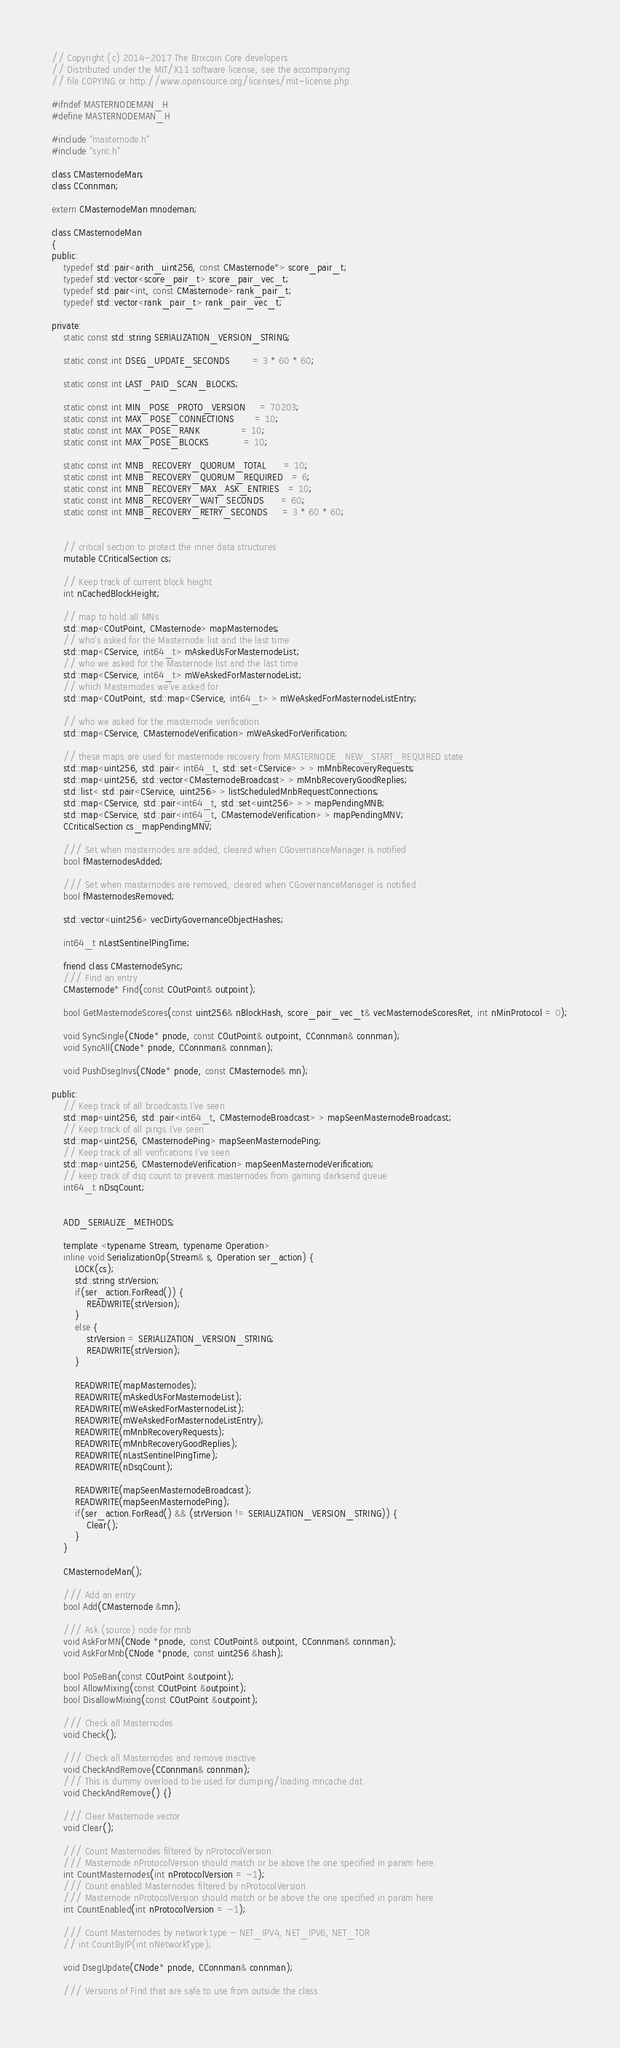<code> <loc_0><loc_0><loc_500><loc_500><_C_>// Copyright (c) 2014-2017 The Brixcoin Core developers
// Distributed under the MIT/X11 software license, see the accompanying
// file COPYING or http://www.opensource.org/licenses/mit-license.php.

#ifndef MASTERNODEMAN_H
#define MASTERNODEMAN_H

#include "masternode.h"
#include "sync.h"

class CMasternodeMan;
class CConnman;

extern CMasternodeMan mnodeman;

class CMasternodeMan
{
public:
    typedef std::pair<arith_uint256, const CMasternode*> score_pair_t;
    typedef std::vector<score_pair_t> score_pair_vec_t;
    typedef std::pair<int, const CMasternode> rank_pair_t;
    typedef std::vector<rank_pair_t> rank_pair_vec_t;

private:
    static const std::string SERIALIZATION_VERSION_STRING;

    static const int DSEG_UPDATE_SECONDS        = 3 * 60 * 60;

    static const int LAST_PAID_SCAN_BLOCKS;

    static const int MIN_POSE_PROTO_VERSION     = 70203;
    static const int MAX_POSE_CONNECTIONS       = 10;
    static const int MAX_POSE_RANK              = 10;
    static const int MAX_POSE_BLOCKS            = 10;

    static const int MNB_RECOVERY_QUORUM_TOTAL      = 10;
    static const int MNB_RECOVERY_QUORUM_REQUIRED   = 6;
    static const int MNB_RECOVERY_MAX_ASK_ENTRIES   = 10;
    static const int MNB_RECOVERY_WAIT_SECONDS      = 60;
    static const int MNB_RECOVERY_RETRY_SECONDS     = 3 * 60 * 60;


    // critical section to protect the inner data structures
    mutable CCriticalSection cs;

    // Keep track of current block height
    int nCachedBlockHeight;

    // map to hold all MNs
    std::map<COutPoint, CMasternode> mapMasternodes;
    // who's asked for the Masternode list and the last time
    std::map<CService, int64_t> mAskedUsForMasternodeList;
    // who we asked for the Masternode list and the last time
    std::map<CService, int64_t> mWeAskedForMasternodeList;
    // which Masternodes we've asked for
    std::map<COutPoint, std::map<CService, int64_t> > mWeAskedForMasternodeListEntry;

    // who we asked for the masternode verification
    std::map<CService, CMasternodeVerification> mWeAskedForVerification;

    // these maps are used for masternode recovery from MASTERNODE_NEW_START_REQUIRED state
    std::map<uint256, std::pair< int64_t, std::set<CService> > > mMnbRecoveryRequests;
    std::map<uint256, std::vector<CMasternodeBroadcast> > mMnbRecoveryGoodReplies;
    std::list< std::pair<CService, uint256> > listScheduledMnbRequestConnections;
    std::map<CService, std::pair<int64_t, std::set<uint256> > > mapPendingMNB;
    std::map<CService, std::pair<int64_t, CMasternodeVerification> > mapPendingMNV;
    CCriticalSection cs_mapPendingMNV;

    /// Set when masternodes are added, cleared when CGovernanceManager is notified
    bool fMasternodesAdded;

    /// Set when masternodes are removed, cleared when CGovernanceManager is notified
    bool fMasternodesRemoved;

    std::vector<uint256> vecDirtyGovernanceObjectHashes;

    int64_t nLastSentinelPingTime;

    friend class CMasternodeSync;
    /// Find an entry
    CMasternode* Find(const COutPoint& outpoint);

    bool GetMasternodeScores(const uint256& nBlockHash, score_pair_vec_t& vecMasternodeScoresRet, int nMinProtocol = 0);

    void SyncSingle(CNode* pnode, const COutPoint& outpoint, CConnman& connman);
    void SyncAll(CNode* pnode, CConnman& connman);

    void PushDsegInvs(CNode* pnode, const CMasternode& mn);

public:
    // Keep track of all broadcasts I've seen
    std::map<uint256, std::pair<int64_t, CMasternodeBroadcast> > mapSeenMasternodeBroadcast;
    // Keep track of all pings I've seen
    std::map<uint256, CMasternodePing> mapSeenMasternodePing;
    // Keep track of all verifications I've seen
    std::map<uint256, CMasternodeVerification> mapSeenMasternodeVerification;
    // keep track of dsq count to prevent masternodes from gaming darksend queue
    int64_t nDsqCount;


    ADD_SERIALIZE_METHODS;

    template <typename Stream, typename Operation>
    inline void SerializationOp(Stream& s, Operation ser_action) {
        LOCK(cs);
        std::string strVersion;
        if(ser_action.ForRead()) {
            READWRITE(strVersion);
        }
        else {
            strVersion = SERIALIZATION_VERSION_STRING; 
            READWRITE(strVersion);
        }

        READWRITE(mapMasternodes);
        READWRITE(mAskedUsForMasternodeList);
        READWRITE(mWeAskedForMasternodeList);
        READWRITE(mWeAskedForMasternodeListEntry);
        READWRITE(mMnbRecoveryRequests);
        READWRITE(mMnbRecoveryGoodReplies);
        READWRITE(nLastSentinelPingTime);
        READWRITE(nDsqCount);

        READWRITE(mapSeenMasternodeBroadcast);
        READWRITE(mapSeenMasternodePing);
        if(ser_action.ForRead() && (strVersion != SERIALIZATION_VERSION_STRING)) {
            Clear();
        }
    }

    CMasternodeMan();

    /// Add an entry
    bool Add(CMasternode &mn);

    /// Ask (source) node for mnb
    void AskForMN(CNode *pnode, const COutPoint& outpoint, CConnman& connman);
    void AskForMnb(CNode *pnode, const uint256 &hash);

    bool PoSeBan(const COutPoint &outpoint);
    bool AllowMixing(const COutPoint &outpoint);
    bool DisallowMixing(const COutPoint &outpoint);

    /// Check all Masternodes
    void Check();

    /// Check all Masternodes and remove inactive
    void CheckAndRemove(CConnman& connman);
    /// This is dummy overload to be used for dumping/loading mncache.dat
    void CheckAndRemove() {}

    /// Clear Masternode vector
    void Clear();

    /// Count Masternodes filtered by nProtocolVersion.
    /// Masternode nProtocolVersion should match or be above the one specified in param here.
    int CountMasternodes(int nProtocolVersion = -1);
    /// Count enabled Masternodes filtered by nProtocolVersion.
    /// Masternode nProtocolVersion should match or be above the one specified in param here.
    int CountEnabled(int nProtocolVersion = -1);

    /// Count Masternodes by network type - NET_IPV4, NET_IPV6, NET_TOR
    // int CountByIP(int nNetworkType);

    void DsegUpdate(CNode* pnode, CConnman& connman);

    /// Versions of Find that are safe to use from outside the class</code> 